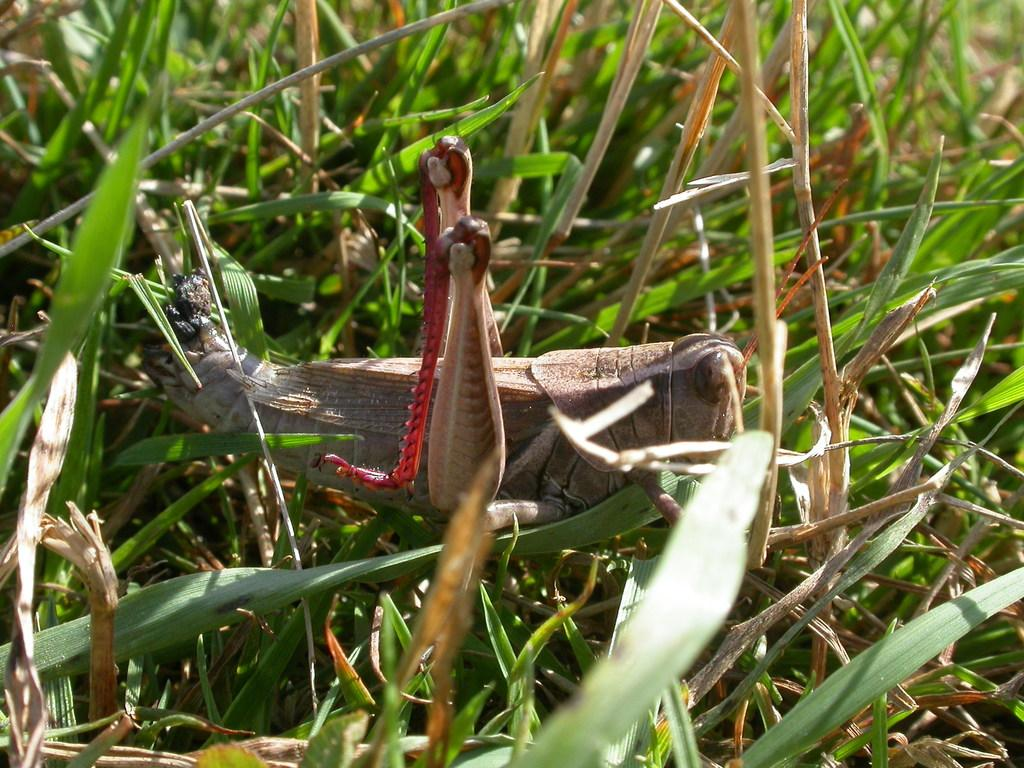What type of living organisms can be seen in the image? Insects and plants are visible in the image. Can you describe the insects in the image? Unfortunately, the facts provided do not give specific details about the insects. What type of plants are present in the image? The facts provided do not give specific details about the plants. What type of lumber is being used to write a message in the image? There is no lumber or writing present in the image; it features are limited to insects and plants. 